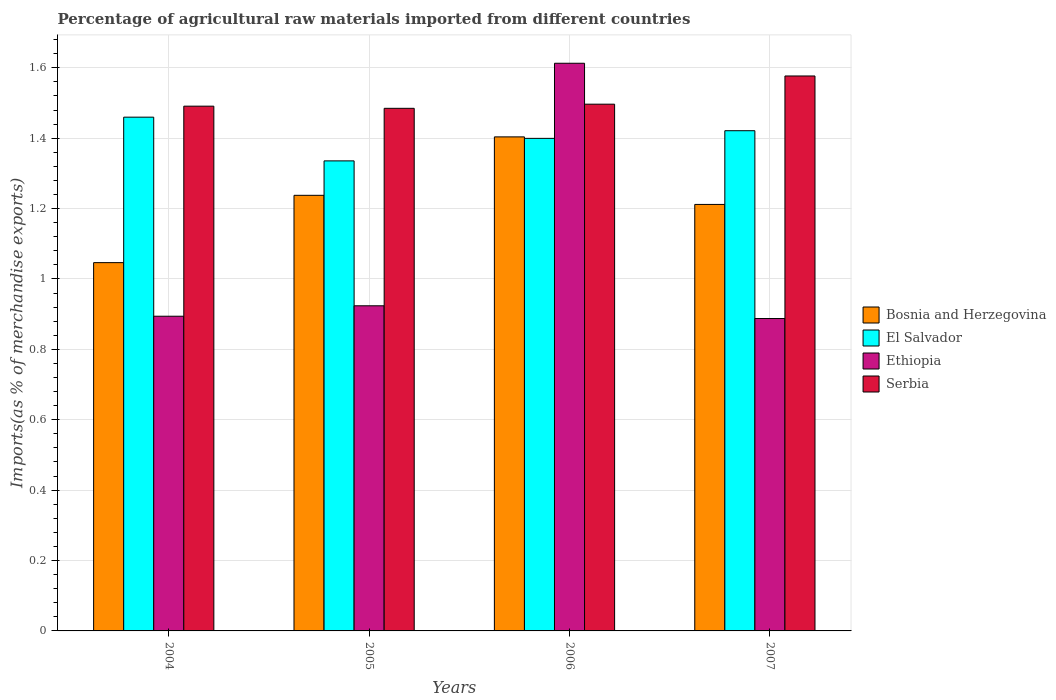How many different coloured bars are there?
Offer a terse response. 4. How many groups of bars are there?
Your answer should be very brief. 4. How many bars are there on the 3rd tick from the left?
Keep it short and to the point. 4. What is the percentage of imports to different countries in El Salvador in 2004?
Give a very brief answer. 1.46. Across all years, what is the maximum percentage of imports to different countries in Bosnia and Herzegovina?
Offer a very short reply. 1.4. Across all years, what is the minimum percentage of imports to different countries in Ethiopia?
Provide a succinct answer. 0.89. In which year was the percentage of imports to different countries in El Salvador minimum?
Offer a very short reply. 2005. What is the total percentage of imports to different countries in Ethiopia in the graph?
Ensure brevity in your answer.  4.32. What is the difference between the percentage of imports to different countries in Bosnia and Herzegovina in 2005 and that in 2006?
Keep it short and to the point. -0.17. What is the difference between the percentage of imports to different countries in Serbia in 2007 and the percentage of imports to different countries in Bosnia and Herzegovina in 2005?
Your answer should be compact. 0.34. What is the average percentage of imports to different countries in Bosnia and Herzegovina per year?
Provide a short and direct response. 1.22. In the year 2005, what is the difference between the percentage of imports to different countries in Bosnia and Herzegovina and percentage of imports to different countries in Serbia?
Your answer should be very brief. -0.25. What is the ratio of the percentage of imports to different countries in El Salvador in 2004 to that in 2007?
Your answer should be compact. 1.03. Is the percentage of imports to different countries in El Salvador in 2006 less than that in 2007?
Give a very brief answer. Yes. What is the difference between the highest and the second highest percentage of imports to different countries in Serbia?
Offer a very short reply. 0.08. What is the difference between the highest and the lowest percentage of imports to different countries in Serbia?
Ensure brevity in your answer.  0.09. Is it the case that in every year, the sum of the percentage of imports to different countries in Bosnia and Herzegovina and percentage of imports to different countries in Serbia is greater than the sum of percentage of imports to different countries in El Salvador and percentage of imports to different countries in Ethiopia?
Offer a terse response. No. What does the 2nd bar from the left in 2004 represents?
Make the answer very short. El Salvador. What does the 3rd bar from the right in 2005 represents?
Keep it short and to the point. El Salvador. Are all the bars in the graph horizontal?
Give a very brief answer. No. Does the graph contain any zero values?
Your response must be concise. No. Where does the legend appear in the graph?
Your answer should be very brief. Center right. How many legend labels are there?
Offer a terse response. 4. What is the title of the graph?
Offer a terse response. Percentage of agricultural raw materials imported from different countries. Does "Middle East & North Africa (developing only)" appear as one of the legend labels in the graph?
Offer a terse response. No. What is the label or title of the X-axis?
Your answer should be compact. Years. What is the label or title of the Y-axis?
Your response must be concise. Imports(as % of merchandise exports). What is the Imports(as % of merchandise exports) in Bosnia and Herzegovina in 2004?
Ensure brevity in your answer.  1.05. What is the Imports(as % of merchandise exports) of El Salvador in 2004?
Your answer should be very brief. 1.46. What is the Imports(as % of merchandise exports) of Ethiopia in 2004?
Keep it short and to the point. 0.89. What is the Imports(as % of merchandise exports) in Serbia in 2004?
Ensure brevity in your answer.  1.49. What is the Imports(as % of merchandise exports) in Bosnia and Herzegovina in 2005?
Provide a succinct answer. 1.24. What is the Imports(as % of merchandise exports) of El Salvador in 2005?
Offer a terse response. 1.34. What is the Imports(as % of merchandise exports) in Ethiopia in 2005?
Your answer should be compact. 0.92. What is the Imports(as % of merchandise exports) in Serbia in 2005?
Your answer should be compact. 1.48. What is the Imports(as % of merchandise exports) in Bosnia and Herzegovina in 2006?
Offer a very short reply. 1.4. What is the Imports(as % of merchandise exports) in El Salvador in 2006?
Your response must be concise. 1.4. What is the Imports(as % of merchandise exports) in Ethiopia in 2006?
Provide a short and direct response. 1.61. What is the Imports(as % of merchandise exports) in Serbia in 2006?
Offer a terse response. 1.5. What is the Imports(as % of merchandise exports) of Bosnia and Herzegovina in 2007?
Your response must be concise. 1.21. What is the Imports(as % of merchandise exports) of El Salvador in 2007?
Your response must be concise. 1.42. What is the Imports(as % of merchandise exports) of Ethiopia in 2007?
Give a very brief answer. 0.89. What is the Imports(as % of merchandise exports) in Serbia in 2007?
Provide a succinct answer. 1.58. Across all years, what is the maximum Imports(as % of merchandise exports) in Bosnia and Herzegovina?
Offer a very short reply. 1.4. Across all years, what is the maximum Imports(as % of merchandise exports) in El Salvador?
Your answer should be very brief. 1.46. Across all years, what is the maximum Imports(as % of merchandise exports) in Ethiopia?
Offer a terse response. 1.61. Across all years, what is the maximum Imports(as % of merchandise exports) in Serbia?
Make the answer very short. 1.58. Across all years, what is the minimum Imports(as % of merchandise exports) in Bosnia and Herzegovina?
Provide a short and direct response. 1.05. Across all years, what is the minimum Imports(as % of merchandise exports) in El Salvador?
Ensure brevity in your answer.  1.34. Across all years, what is the minimum Imports(as % of merchandise exports) in Ethiopia?
Your response must be concise. 0.89. Across all years, what is the minimum Imports(as % of merchandise exports) of Serbia?
Give a very brief answer. 1.48. What is the total Imports(as % of merchandise exports) in Bosnia and Herzegovina in the graph?
Ensure brevity in your answer.  4.9. What is the total Imports(as % of merchandise exports) of El Salvador in the graph?
Give a very brief answer. 5.62. What is the total Imports(as % of merchandise exports) of Ethiopia in the graph?
Provide a succinct answer. 4.32. What is the total Imports(as % of merchandise exports) in Serbia in the graph?
Ensure brevity in your answer.  6.05. What is the difference between the Imports(as % of merchandise exports) of Bosnia and Herzegovina in 2004 and that in 2005?
Keep it short and to the point. -0.19. What is the difference between the Imports(as % of merchandise exports) of El Salvador in 2004 and that in 2005?
Your answer should be very brief. 0.12. What is the difference between the Imports(as % of merchandise exports) of Ethiopia in 2004 and that in 2005?
Your answer should be compact. -0.03. What is the difference between the Imports(as % of merchandise exports) of Serbia in 2004 and that in 2005?
Make the answer very short. 0.01. What is the difference between the Imports(as % of merchandise exports) of Bosnia and Herzegovina in 2004 and that in 2006?
Provide a succinct answer. -0.36. What is the difference between the Imports(as % of merchandise exports) of El Salvador in 2004 and that in 2006?
Offer a very short reply. 0.06. What is the difference between the Imports(as % of merchandise exports) of Ethiopia in 2004 and that in 2006?
Offer a very short reply. -0.72. What is the difference between the Imports(as % of merchandise exports) in Serbia in 2004 and that in 2006?
Offer a very short reply. -0.01. What is the difference between the Imports(as % of merchandise exports) of Bosnia and Herzegovina in 2004 and that in 2007?
Give a very brief answer. -0.17. What is the difference between the Imports(as % of merchandise exports) in El Salvador in 2004 and that in 2007?
Offer a terse response. 0.04. What is the difference between the Imports(as % of merchandise exports) in Ethiopia in 2004 and that in 2007?
Provide a succinct answer. 0.01. What is the difference between the Imports(as % of merchandise exports) of Serbia in 2004 and that in 2007?
Provide a short and direct response. -0.09. What is the difference between the Imports(as % of merchandise exports) of Bosnia and Herzegovina in 2005 and that in 2006?
Your answer should be compact. -0.17. What is the difference between the Imports(as % of merchandise exports) in El Salvador in 2005 and that in 2006?
Provide a succinct answer. -0.06. What is the difference between the Imports(as % of merchandise exports) of Ethiopia in 2005 and that in 2006?
Ensure brevity in your answer.  -0.69. What is the difference between the Imports(as % of merchandise exports) in Serbia in 2005 and that in 2006?
Your answer should be very brief. -0.01. What is the difference between the Imports(as % of merchandise exports) in Bosnia and Herzegovina in 2005 and that in 2007?
Provide a short and direct response. 0.03. What is the difference between the Imports(as % of merchandise exports) in El Salvador in 2005 and that in 2007?
Your answer should be very brief. -0.09. What is the difference between the Imports(as % of merchandise exports) of Ethiopia in 2005 and that in 2007?
Offer a very short reply. 0.04. What is the difference between the Imports(as % of merchandise exports) in Serbia in 2005 and that in 2007?
Make the answer very short. -0.09. What is the difference between the Imports(as % of merchandise exports) of Bosnia and Herzegovina in 2006 and that in 2007?
Your response must be concise. 0.19. What is the difference between the Imports(as % of merchandise exports) in El Salvador in 2006 and that in 2007?
Your answer should be very brief. -0.02. What is the difference between the Imports(as % of merchandise exports) in Ethiopia in 2006 and that in 2007?
Provide a succinct answer. 0.73. What is the difference between the Imports(as % of merchandise exports) in Serbia in 2006 and that in 2007?
Provide a short and direct response. -0.08. What is the difference between the Imports(as % of merchandise exports) in Bosnia and Herzegovina in 2004 and the Imports(as % of merchandise exports) in El Salvador in 2005?
Provide a short and direct response. -0.29. What is the difference between the Imports(as % of merchandise exports) of Bosnia and Herzegovina in 2004 and the Imports(as % of merchandise exports) of Ethiopia in 2005?
Ensure brevity in your answer.  0.12. What is the difference between the Imports(as % of merchandise exports) of Bosnia and Herzegovina in 2004 and the Imports(as % of merchandise exports) of Serbia in 2005?
Make the answer very short. -0.44. What is the difference between the Imports(as % of merchandise exports) in El Salvador in 2004 and the Imports(as % of merchandise exports) in Ethiopia in 2005?
Your response must be concise. 0.54. What is the difference between the Imports(as % of merchandise exports) of El Salvador in 2004 and the Imports(as % of merchandise exports) of Serbia in 2005?
Provide a short and direct response. -0.03. What is the difference between the Imports(as % of merchandise exports) in Ethiopia in 2004 and the Imports(as % of merchandise exports) in Serbia in 2005?
Offer a terse response. -0.59. What is the difference between the Imports(as % of merchandise exports) of Bosnia and Herzegovina in 2004 and the Imports(as % of merchandise exports) of El Salvador in 2006?
Provide a succinct answer. -0.35. What is the difference between the Imports(as % of merchandise exports) of Bosnia and Herzegovina in 2004 and the Imports(as % of merchandise exports) of Ethiopia in 2006?
Provide a short and direct response. -0.57. What is the difference between the Imports(as % of merchandise exports) in Bosnia and Herzegovina in 2004 and the Imports(as % of merchandise exports) in Serbia in 2006?
Offer a very short reply. -0.45. What is the difference between the Imports(as % of merchandise exports) in El Salvador in 2004 and the Imports(as % of merchandise exports) in Ethiopia in 2006?
Your answer should be compact. -0.15. What is the difference between the Imports(as % of merchandise exports) in El Salvador in 2004 and the Imports(as % of merchandise exports) in Serbia in 2006?
Provide a succinct answer. -0.04. What is the difference between the Imports(as % of merchandise exports) in Ethiopia in 2004 and the Imports(as % of merchandise exports) in Serbia in 2006?
Ensure brevity in your answer.  -0.6. What is the difference between the Imports(as % of merchandise exports) of Bosnia and Herzegovina in 2004 and the Imports(as % of merchandise exports) of El Salvador in 2007?
Give a very brief answer. -0.37. What is the difference between the Imports(as % of merchandise exports) of Bosnia and Herzegovina in 2004 and the Imports(as % of merchandise exports) of Ethiopia in 2007?
Your answer should be compact. 0.16. What is the difference between the Imports(as % of merchandise exports) in Bosnia and Herzegovina in 2004 and the Imports(as % of merchandise exports) in Serbia in 2007?
Offer a very short reply. -0.53. What is the difference between the Imports(as % of merchandise exports) of El Salvador in 2004 and the Imports(as % of merchandise exports) of Ethiopia in 2007?
Provide a succinct answer. 0.57. What is the difference between the Imports(as % of merchandise exports) of El Salvador in 2004 and the Imports(as % of merchandise exports) of Serbia in 2007?
Offer a very short reply. -0.12. What is the difference between the Imports(as % of merchandise exports) in Ethiopia in 2004 and the Imports(as % of merchandise exports) in Serbia in 2007?
Offer a very short reply. -0.68. What is the difference between the Imports(as % of merchandise exports) in Bosnia and Herzegovina in 2005 and the Imports(as % of merchandise exports) in El Salvador in 2006?
Give a very brief answer. -0.16. What is the difference between the Imports(as % of merchandise exports) in Bosnia and Herzegovina in 2005 and the Imports(as % of merchandise exports) in Ethiopia in 2006?
Your answer should be very brief. -0.38. What is the difference between the Imports(as % of merchandise exports) in Bosnia and Herzegovina in 2005 and the Imports(as % of merchandise exports) in Serbia in 2006?
Make the answer very short. -0.26. What is the difference between the Imports(as % of merchandise exports) in El Salvador in 2005 and the Imports(as % of merchandise exports) in Ethiopia in 2006?
Your answer should be compact. -0.28. What is the difference between the Imports(as % of merchandise exports) of El Salvador in 2005 and the Imports(as % of merchandise exports) of Serbia in 2006?
Provide a succinct answer. -0.16. What is the difference between the Imports(as % of merchandise exports) in Ethiopia in 2005 and the Imports(as % of merchandise exports) in Serbia in 2006?
Provide a short and direct response. -0.57. What is the difference between the Imports(as % of merchandise exports) in Bosnia and Herzegovina in 2005 and the Imports(as % of merchandise exports) in El Salvador in 2007?
Keep it short and to the point. -0.18. What is the difference between the Imports(as % of merchandise exports) in Bosnia and Herzegovina in 2005 and the Imports(as % of merchandise exports) in Ethiopia in 2007?
Your answer should be compact. 0.35. What is the difference between the Imports(as % of merchandise exports) of Bosnia and Herzegovina in 2005 and the Imports(as % of merchandise exports) of Serbia in 2007?
Ensure brevity in your answer.  -0.34. What is the difference between the Imports(as % of merchandise exports) of El Salvador in 2005 and the Imports(as % of merchandise exports) of Ethiopia in 2007?
Your answer should be very brief. 0.45. What is the difference between the Imports(as % of merchandise exports) of El Salvador in 2005 and the Imports(as % of merchandise exports) of Serbia in 2007?
Keep it short and to the point. -0.24. What is the difference between the Imports(as % of merchandise exports) in Ethiopia in 2005 and the Imports(as % of merchandise exports) in Serbia in 2007?
Your response must be concise. -0.65. What is the difference between the Imports(as % of merchandise exports) in Bosnia and Herzegovina in 2006 and the Imports(as % of merchandise exports) in El Salvador in 2007?
Make the answer very short. -0.02. What is the difference between the Imports(as % of merchandise exports) in Bosnia and Herzegovina in 2006 and the Imports(as % of merchandise exports) in Ethiopia in 2007?
Your answer should be very brief. 0.52. What is the difference between the Imports(as % of merchandise exports) of Bosnia and Herzegovina in 2006 and the Imports(as % of merchandise exports) of Serbia in 2007?
Give a very brief answer. -0.17. What is the difference between the Imports(as % of merchandise exports) in El Salvador in 2006 and the Imports(as % of merchandise exports) in Ethiopia in 2007?
Give a very brief answer. 0.51. What is the difference between the Imports(as % of merchandise exports) in El Salvador in 2006 and the Imports(as % of merchandise exports) in Serbia in 2007?
Make the answer very short. -0.18. What is the difference between the Imports(as % of merchandise exports) in Ethiopia in 2006 and the Imports(as % of merchandise exports) in Serbia in 2007?
Your response must be concise. 0.04. What is the average Imports(as % of merchandise exports) in Bosnia and Herzegovina per year?
Provide a short and direct response. 1.23. What is the average Imports(as % of merchandise exports) in El Salvador per year?
Keep it short and to the point. 1.4. What is the average Imports(as % of merchandise exports) in Ethiopia per year?
Provide a succinct answer. 1.08. What is the average Imports(as % of merchandise exports) of Serbia per year?
Provide a succinct answer. 1.51. In the year 2004, what is the difference between the Imports(as % of merchandise exports) of Bosnia and Herzegovina and Imports(as % of merchandise exports) of El Salvador?
Ensure brevity in your answer.  -0.41. In the year 2004, what is the difference between the Imports(as % of merchandise exports) in Bosnia and Herzegovina and Imports(as % of merchandise exports) in Ethiopia?
Your answer should be compact. 0.15. In the year 2004, what is the difference between the Imports(as % of merchandise exports) in Bosnia and Herzegovina and Imports(as % of merchandise exports) in Serbia?
Give a very brief answer. -0.44. In the year 2004, what is the difference between the Imports(as % of merchandise exports) of El Salvador and Imports(as % of merchandise exports) of Ethiopia?
Offer a very short reply. 0.57. In the year 2004, what is the difference between the Imports(as % of merchandise exports) of El Salvador and Imports(as % of merchandise exports) of Serbia?
Provide a short and direct response. -0.03. In the year 2004, what is the difference between the Imports(as % of merchandise exports) of Ethiopia and Imports(as % of merchandise exports) of Serbia?
Your answer should be compact. -0.6. In the year 2005, what is the difference between the Imports(as % of merchandise exports) in Bosnia and Herzegovina and Imports(as % of merchandise exports) in El Salvador?
Offer a very short reply. -0.1. In the year 2005, what is the difference between the Imports(as % of merchandise exports) of Bosnia and Herzegovina and Imports(as % of merchandise exports) of Ethiopia?
Provide a succinct answer. 0.31. In the year 2005, what is the difference between the Imports(as % of merchandise exports) of Bosnia and Herzegovina and Imports(as % of merchandise exports) of Serbia?
Offer a terse response. -0.25. In the year 2005, what is the difference between the Imports(as % of merchandise exports) of El Salvador and Imports(as % of merchandise exports) of Ethiopia?
Ensure brevity in your answer.  0.41. In the year 2005, what is the difference between the Imports(as % of merchandise exports) of El Salvador and Imports(as % of merchandise exports) of Serbia?
Keep it short and to the point. -0.15. In the year 2005, what is the difference between the Imports(as % of merchandise exports) in Ethiopia and Imports(as % of merchandise exports) in Serbia?
Your answer should be very brief. -0.56. In the year 2006, what is the difference between the Imports(as % of merchandise exports) of Bosnia and Herzegovina and Imports(as % of merchandise exports) of El Salvador?
Provide a short and direct response. 0. In the year 2006, what is the difference between the Imports(as % of merchandise exports) in Bosnia and Herzegovina and Imports(as % of merchandise exports) in Ethiopia?
Your answer should be very brief. -0.21. In the year 2006, what is the difference between the Imports(as % of merchandise exports) in Bosnia and Herzegovina and Imports(as % of merchandise exports) in Serbia?
Make the answer very short. -0.09. In the year 2006, what is the difference between the Imports(as % of merchandise exports) in El Salvador and Imports(as % of merchandise exports) in Ethiopia?
Ensure brevity in your answer.  -0.21. In the year 2006, what is the difference between the Imports(as % of merchandise exports) of El Salvador and Imports(as % of merchandise exports) of Serbia?
Keep it short and to the point. -0.1. In the year 2006, what is the difference between the Imports(as % of merchandise exports) of Ethiopia and Imports(as % of merchandise exports) of Serbia?
Provide a succinct answer. 0.12. In the year 2007, what is the difference between the Imports(as % of merchandise exports) of Bosnia and Herzegovina and Imports(as % of merchandise exports) of El Salvador?
Your answer should be very brief. -0.21. In the year 2007, what is the difference between the Imports(as % of merchandise exports) in Bosnia and Herzegovina and Imports(as % of merchandise exports) in Ethiopia?
Make the answer very short. 0.32. In the year 2007, what is the difference between the Imports(as % of merchandise exports) in Bosnia and Herzegovina and Imports(as % of merchandise exports) in Serbia?
Your answer should be compact. -0.36. In the year 2007, what is the difference between the Imports(as % of merchandise exports) in El Salvador and Imports(as % of merchandise exports) in Ethiopia?
Provide a succinct answer. 0.53. In the year 2007, what is the difference between the Imports(as % of merchandise exports) of El Salvador and Imports(as % of merchandise exports) of Serbia?
Make the answer very short. -0.16. In the year 2007, what is the difference between the Imports(as % of merchandise exports) in Ethiopia and Imports(as % of merchandise exports) in Serbia?
Make the answer very short. -0.69. What is the ratio of the Imports(as % of merchandise exports) of Bosnia and Herzegovina in 2004 to that in 2005?
Offer a terse response. 0.85. What is the ratio of the Imports(as % of merchandise exports) of El Salvador in 2004 to that in 2005?
Your answer should be compact. 1.09. What is the ratio of the Imports(as % of merchandise exports) in Ethiopia in 2004 to that in 2005?
Offer a very short reply. 0.97. What is the ratio of the Imports(as % of merchandise exports) of Bosnia and Herzegovina in 2004 to that in 2006?
Make the answer very short. 0.75. What is the ratio of the Imports(as % of merchandise exports) in El Salvador in 2004 to that in 2006?
Your response must be concise. 1.04. What is the ratio of the Imports(as % of merchandise exports) of Ethiopia in 2004 to that in 2006?
Provide a succinct answer. 0.55. What is the ratio of the Imports(as % of merchandise exports) in Serbia in 2004 to that in 2006?
Your answer should be compact. 1. What is the ratio of the Imports(as % of merchandise exports) of Bosnia and Herzegovina in 2004 to that in 2007?
Offer a very short reply. 0.86. What is the ratio of the Imports(as % of merchandise exports) of El Salvador in 2004 to that in 2007?
Keep it short and to the point. 1.03. What is the ratio of the Imports(as % of merchandise exports) of Ethiopia in 2004 to that in 2007?
Your answer should be compact. 1.01. What is the ratio of the Imports(as % of merchandise exports) in Serbia in 2004 to that in 2007?
Your answer should be compact. 0.95. What is the ratio of the Imports(as % of merchandise exports) in Bosnia and Herzegovina in 2005 to that in 2006?
Your answer should be very brief. 0.88. What is the ratio of the Imports(as % of merchandise exports) in El Salvador in 2005 to that in 2006?
Keep it short and to the point. 0.95. What is the ratio of the Imports(as % of merchandise exports) in Ethiopia in 2005 to that in 2006?
Keep it short and to the point. 0.57. What is the ratio of the Imports(as % of merchandise exports) in Serbia in 2005 to that in 2006?
Your answer should be compact. 0.99. What is the ratio of the Imports(as % of merchandise exports) in Bosnia and Herzegovina in 2005 to that in 2007?
Provide a short and direct response. 1.02. What is the ratio of the Imports(as % of merchandise exports) in El Salvador in 2005 to that in 2007?
Offer a terse response. 0.94. What is the ratio of the Imports(as % of merchandise exports) of Ethiopia in 2005 to that in 2007?
Provide a succinct answer. 1.04. What is the ratio of the Imports(as % of merchandise exports) of Serbia in 2005 to that in 2007?
Provide a succinct answer. 0.94. What is the ratio of the Imports(as % of merchandise exports) of Bosnia and Herzegovina in 2006 to that in 2007?
Provide a succinct answer. 1.16. What is the ratio of the Imports(as % of merchandise exports) in El Salvador in 2006 to that in 2007?
Offer a terse response. 0.98. What is the ratio of the Imports(as % of merchandise exports) of Ethiopia in 2006 to that in 2007?
Your response must be concise. 1.82. What is the ratio of the Imports(as % of merchandise exports) in Serbia in 2006 to that in 2007?
Give a very brief answer. 0.95. What is the difference between the highest and the second highest Imports(as % of merchandise exports) in Bosnia and Herzegovina?
Provide a short and direct response. 0.17. What is the difference between the highest and the second highest Imports(as % of merchandise exports) of El Salvador?
Offer a terse response. 0.04. What is the difference between the highest and the second highest Imports(as % of merchandise exports) of Ethiopia?
Offer a very short reply. 0.69. What is the difference between the highest and the second highest Imports(as % of merchandise exports) of Serbia?
Give a very brief answer. 0.08. What is the difference between the highest and the lowest Imports(as % of merchandise exports) in Bosnia and Herzegovina?
Offer a terse response. 0.36. What is the difference between the highest and the lowest Imports(as % of merchandise exports) in El Salvador?
Make the answer very short. 0.12. What is the difference between the highest and the lowest Imports(as % of merchandise exports) in Ethiopia?
Offer a terse response. 0.73. What is the difference between the highest and the lowest Imports(as % of merchandise exports) of Serbia?
Your answer should be very brief. 0.09. 